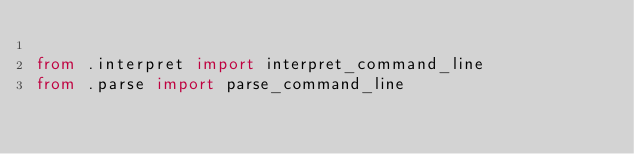<code> <loc_0><loc_0><loc_500><loc_500><_Python_>
from .interpret import interpret_command_line
from .parse import parse_command_line
</code> 